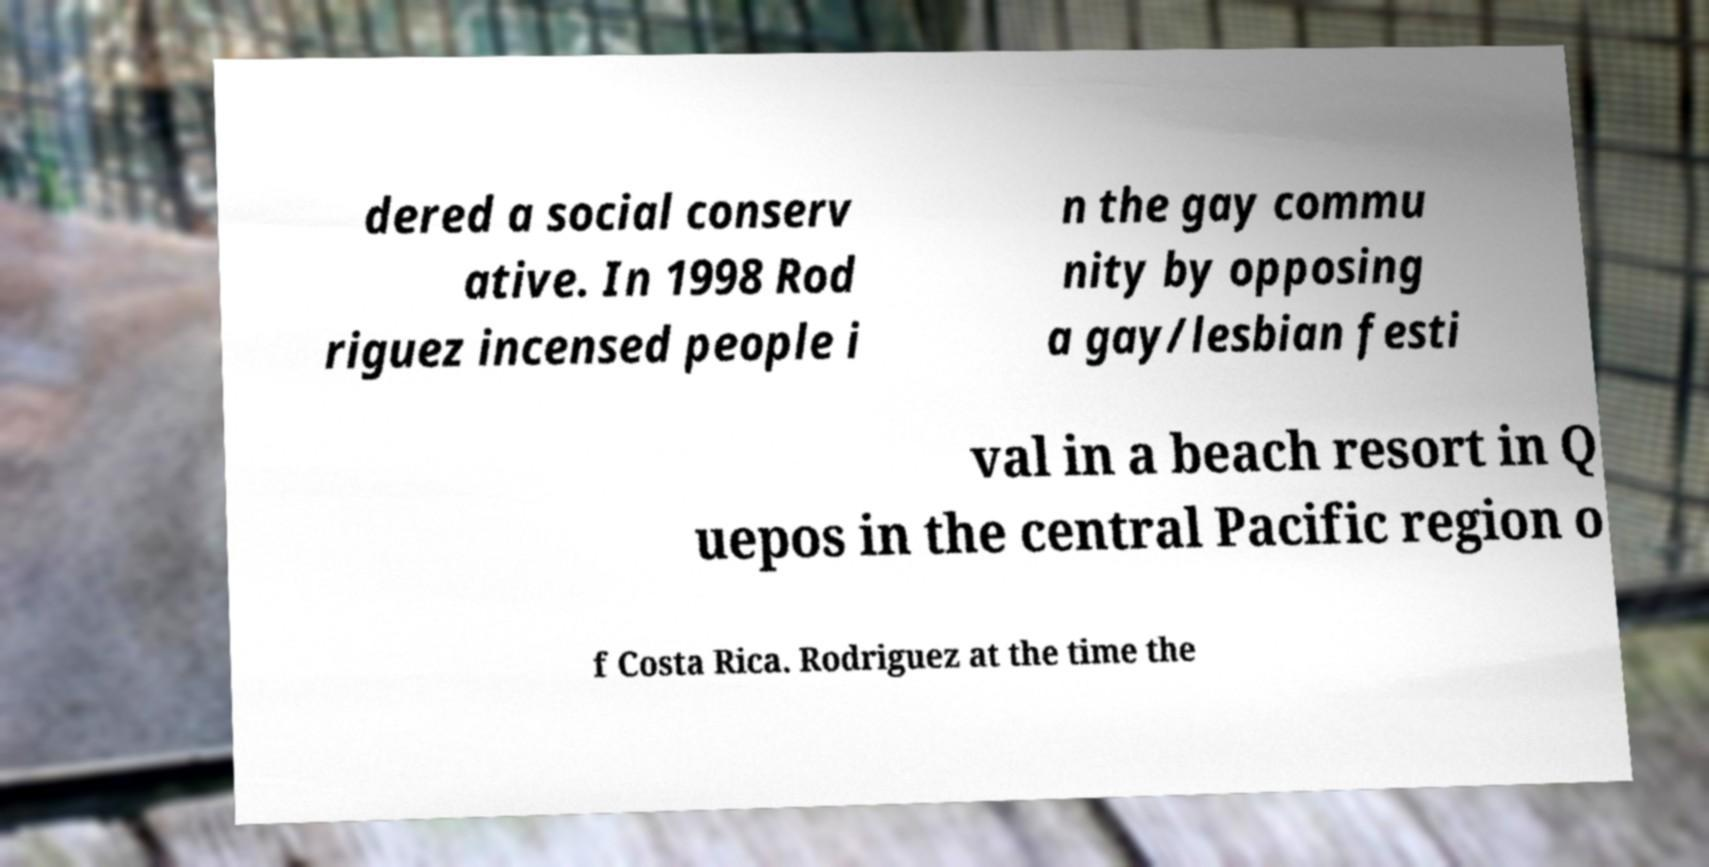Could you assist in decoding the text presented in this image and type it out clearly? dered a social conserv ative. In 1998 Rod riguez incensed people i n the gay commu nity by opposing a gay/lesbian festi val in a beach resort in Q uepos in the central Pacific region o f Costa Rica. Rodriguez at the time the 